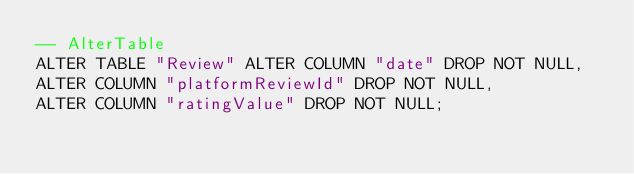<code> <loc_0><loc_0><loc_500><loc_500><_SQL_>-- AlterTable
ALTER TABLE "Review" ALTER COLUMN "date" DROP NOT NULL,
ALTER COLUMN "platformReviewId" DROP NOT NULL,
ALTER COLUMN "ratingValue" DROP NOT NULL;
</code> 